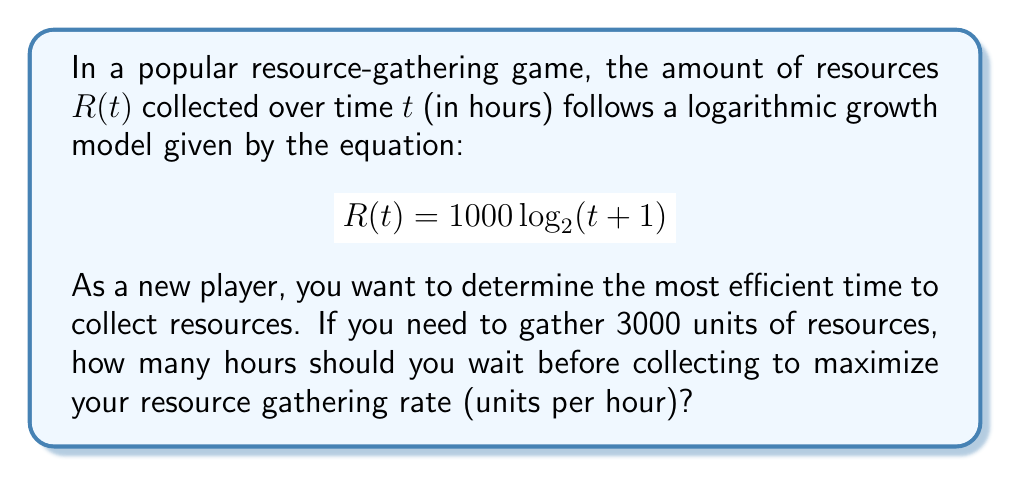Give your solution to this math problem. To solve this problem, we need to follow these steps:

1) First, let's understand what the question is asking. We need to find the time $t$ that maximizes the resource gathering rate. The rate is defined as the amount of resources collected divided by the time spent.

2) We can express this rate as a function of time:

   $$\text{Rate}(t) = \frac{R(t)}{t} = \frac{1000 \log_2(t+1)}{t}$$

3) To find the maximum of this function, we need to differentiate it with respect to $t$ and set it equal to zero. However, this leads to a complex equation that's difficult to solve algebraically.

4) Instead, we can use the given information that we need to collect 3000 units of resources. We can find the time it takes to collect this amount:

   $$3000 = 1000 \log_2(t+1)$$
   $$3 = \log_2(t+1)$$
   $$2^3 = t+1$$
   $$t = 7$$

5) This means it takes 7 hours to collect 3000 units of resources.

6) Now, let's calculate the rate at this time:

   $$\text{Rate}(7) = \frac{3000}{7} \approx 428.57 \text{ units/hour}$$

7) This is the maximum rate for collecting 3000 units. If you wait longer, you'll have more resources, but your rate will decrease. If you collect earlier, you'll have a lower rate because of the logarithmic nature of the growth.
Answer: You should wait 7 hours before collecting resources to maximize your resource gathering rate, which will be approximately 428.57 units per hour. 